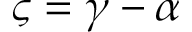Convert formula to latex. <formula><loc_0><loc_0><loc_500><loc_500>\varsigma = \gamma - \alpha</formula> 